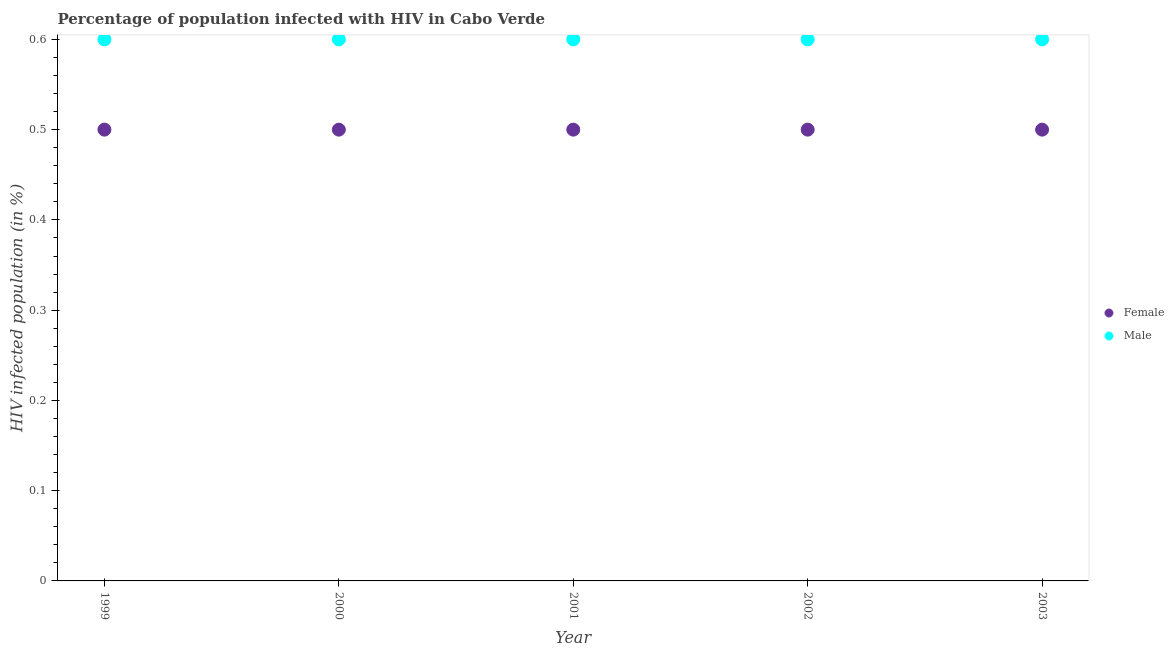How many different coloured dotlines are there?
Your answer should be compact. 2. What is the percentage of females who are infected with hiv in 2000?
Your answer should be very brief. 0.5. Across all years, what is the minimum percentage of males who are infected with hiv?
Keep it short and to the point. 0.6. In which year was the percentage of females who are infected with hiv maximum?
Offer a terse response. 1999. What is the difference between the percentage of females who are infected with hiv in 2001 and the percentage of males who are infected with hiv in 2002?
Provide a short and direct response. -0.1. What is the average percentage of females who are infected with hiv per year?
Your response must be concise. 0.5. In the year 2001, what is the difference between the percentage of females who are infected with hiv and percentage of males who are infected with hiv?
Offer a terse response. -0.1. In how many years, is the percentage of females who are infected with hiv greater than 0.54 %?
Your answer should be very brief. 0. Is the difference between the percentage of females who are infected with hiv in 2001 and 2002 greater than the difference between the percentage of males who are infected with hiv in 2001 and 2002?
Your answer should be very brief. No. What is the difference between the highest and the second highest percentage of males who are infected with hiv?
Provide a succinct answer. 0. Is the percentage of males who are infected with hiv strictly greater than the percentage of females who are infected with hiv over the years?
Offer a terse response. Yes. Is the percentage of males who are infected with hiv strictly less than the percentage of females who are infected with hiv over the years?
Ensure brevity in your answer.  No. How many years are there in the graph?
Give a very brief answer. 5. Are the values on the major ticks of Y-axis written in scientific E-notation?
Provide a short and direct response. No. Does the graph contain any zero values?
Provide a succinct answer. No. Where does the legend appear in the graph?
Make the answer very short. Center right. What is the title of the graph?
Your answer should be compact. Percentage of population infected with HIV in Cabo Verde. What is the label or title of the X-axis?
Your answer should be very brief. Year. What is the label or title of the Y-axis?
Offer a very short reply. HIV infected population (in %). What is the HIV infected population (in %) of Female in 1999?
Your answer should be very brief. 0.5. What is the HIV infected population (in %) in Female in 2000?
Your answer should be very brief. 0.5. What is the HIV infected population (in %) in Female in 2003?
Your response must be concise. 0.5. Across all years, what is the minimum HIV infected population (in %) of Female?
Your response must be concise. 0.5. What is the total HIV infected population (in %) in Male in the graph?
Offer a very short reply. 3. What is the difference between the HIV infected population (in %) in Female in 1999 and that in 2000?
Offer a terse response. 0. What is the difference between the HIV infected population (in %) of Male in 1999 and that in 2000?
Offer a very short reply. 0. What is the difference between the HIV infected population (in %) in Male in 1999 and that in 2003?
Provide a succinct answer. 0. What is the difference between the HIV infected population (in %) in Male in 2000 and that in 2001?
Make the answer very short. 0. What is the difference between the HIV infected population (in %) of Male in 2000 and that in 2002?
Give a very brief answer. 0. What is the difference between the HIV infected population (in %) of Female in 2000 and that in 2003?
Your answer should be very brief. 0. What is the difference between the HIV infected population (in %) in Male in 2001 and that in 2002?
Your answer should be very brief. 0. What is the difference between the HIV infected population (in %) in Female in 2001 and that in 2003?
Give a very brief answer. 0. What is the difference between the HIV infected population (in %) of Male in 2001 and that in 2003?
Provide a short and direct response. 0. What is the difference between the HIV infected population (in %) of Female in 1999 and the HIV infected population (in %) of Male in 2000?
Offer a terse response. -0.1. What is the difference between the HIV infected population (in %) of Female in 1999 and the HIV infected population (in %) of Male in 2002?
Offer a terse response. -0.1. What is the difference between the HIV infected population (in %) in Female in 2000 and the HIV infected population (in %) in Male in 2001?
Keep it short and to the point. -0.1. What is the difference between the HIV infected population (in %) in Female in 2000 and the HIV infected population (in %) in Male in 2002?
Make the answer very short. -0.1. What is the difference between the HIV infected population (in %) in Female in 2000 and the HIV infected population (in %) in Male in 2003?
Your response must be concise. -0.1. What is the difference between the HIV infected population (in %) in Female in 2001 and the HIV infected population (in %) in Male in 2002?
Ensure brevity in your answer.  -0.1. What is the average HIV infected population (in %) of Female per year?
Offer a very short reply. 0.5. In the year 1999, what is the difference between the HIV infected population (in %) of Female and HIV infected population (in %) of Male?
Make the answer very short. -0.1. In the year 2002, what is the difference between the HIV infected population (in %) of Female and HIV infected population (in %) of Male?
Provide a short and direct response. -0.1. In the year 2003, what is the difference between the HIV infected population (in %) of Female and HIV infected population (in %) of Male?
Keep it short and to the point. -0.1. What is the ratio of the HIV infected population (in %) in Female in 1999 to that in 2000?
Your answer should be very brief. 1. What is the ratio of the HIV infected population (in %) of Male in 1999 to that in 2000?
Provide a short and direct response. 1. What is the ratio of the HIV infected population (in %) in Female in 1999 to that in 2001?
Your response must be concise. 1. What is the ratio of the HIV infected population (in %) of Male in 1999 to that in 2001?
Offer a very short reply. 1. What is the ratio of the HIV infected population (in %) in Female in 1999 to that in 2003?
Make the answer very short. 1. What is the ratio of the HIV infected population (in %) of Male in 1999 to that in 2003?
Your response must be concise. 1. What is the ratio of the HIV infected population (in %) in Female in 2000 to that in 2001?
Keep it short and to the point. 1. What is the ratio of the HIV infected population (in %) in Male in 2000 to that in 2002?
Your answer should be compact. 1. What is the ratio of the HIV infected population (in %) of Male in 2000 to that in 2003?
Keep it short and to the point. 1. What is the ratio of the HIV infected population (in %) of Female in 2001 to that in 2002?
Ensure brevity in your answer.  1. What is the ratio of the HIV infected population (in %) in Male in 2001 to that in 2002?
Give a very brief answer. 1. What is the ratio of the HIV infected population (in %) of Female in 2001 to that in 2003?
Your response must be concise. 1. What is the ratio of the HIV infected population (in %) in Male in 2001 to that in 2003?
Your answer should be compact. 1. What is the ratio of the HIV infected population (in %) in Male in 2002 to that in 2003?
Make the answer very short. 1. What is the difference between the highest and the second highest HIV infected population (in %) of Female?
Provide a succinct answer. 0. What is the difference between the highest and the second highest HIV infected population (in %) in Male?
Keep it short and to the point. 0. 